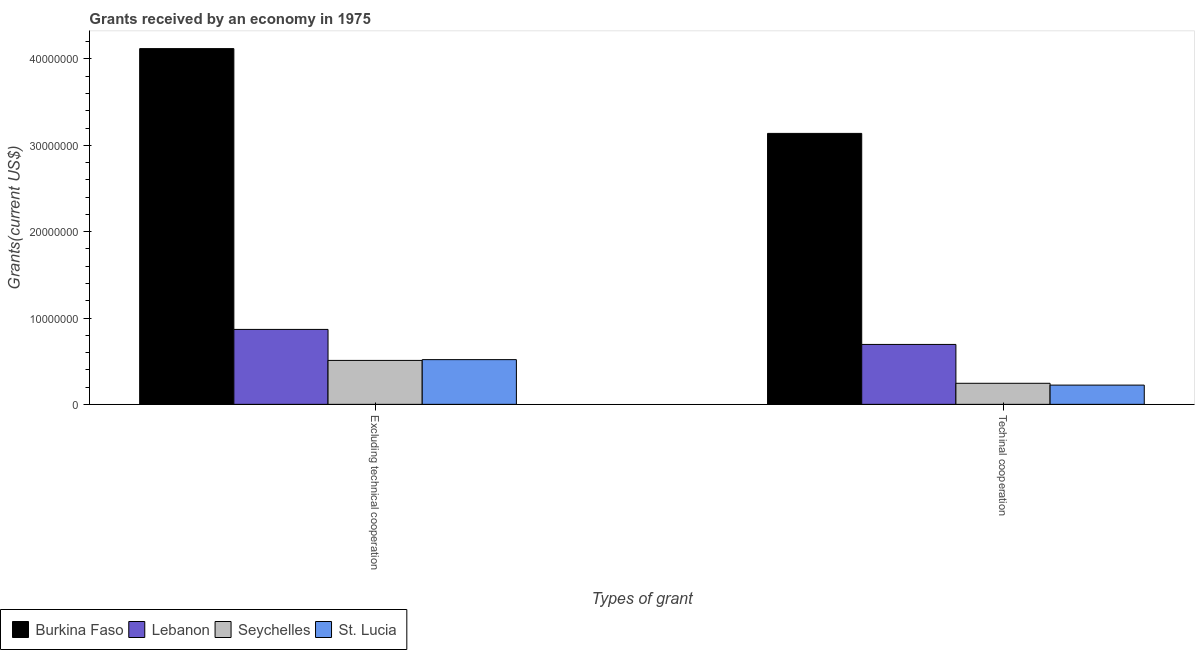How many groups of bars are there?
Your answer should be compact. 2. Are the number of bars on each tick of the X-axis equal?
Give a very brief answer. Yes. What is the label of the 2nd group of bars from the left?
Your answer should be compact. Techinal cooperation. What is the amount of grants received(including technical cooperation) in Seychelles?
Your response must be concise. 2.44e+06. Across all countries, what is the maximum amount of grants received(including technical cooperation)?
Keep it short and to the point. 3.14e+07. Across all countries, what is the minimum amount of grants received(including technical cooperation)?
Give a very brief answer. 2.23e+06. In which country was the amount of grants received(including technical cooperation) maximum?
Offer a very short reply. Burkina Faso. In which country was the amount of grants received(including technical cooperation) minimum?
Provide a succinct answer. St. Lucia. What is the total amount of grants received(including technical cooperation) in the graph?
Your answer should be compact. 4.30e+07. What is the difference between the amount of grants received(excluding technical cooperation) in Lebanon and that in Burkina Faso?
Provide a succinct answer. -3.25e+07. What is the difference between the amount of grants received(excluding technical cooperation) in Burkina Faso and the amount of grants received(including technical cooperation) in Seychelles?
Keep it short and to the point. 3.88e+07. What is the average amount of grants received(including technical cooperation) per country?
Your answer should be very brief. 1.07e+07. What is the difference between the amount of grants received(excluding technical cooperation) and amount of grants received(including technical cooperation) in Seychelles?
Offer a terse response. 2.65e+06. What is the ratio of the amount of grants received(including technical cooperation) in Seychelles to that in Burkina Faso?
Make the answer very short. 0.08. Is the amount of grants received(including technical cooperation) in Seychelles less than that in St. Lucia?
Your answer should be compact. No. In how many countries, is the amount of grants received(including technical cooperation) greater than the average amount of grants received(including technical cooperation) taken over all countries?
Your answer should be very brief. 1. What does the 3rd bar from the left in Techinal cooperation represents?
Make the answer very short. Seychelles. What does the 3rd bar from the right in Excluding technical cooperation represents?
Your answer should be very brief. Lebanon. How many bars are there?
Offer a terse response. 8. Are all the bars in the graph horizontal?
Your answer should be compact. No. How many countries are there in the graph?
Provide a succinct answer. 4. Does the graph contain any zero values?
Offer a very short reply. No. How many legend labels are there?
Provide a short and direct response. 4. What is the title of the graph?
Ensure brevity in your answer.  Grants received by an economy in 1975. What is the label or title of the X-axis?
Provide a succinct answer. Types of grant. What is the label or title of the Y-axis?
Keep it short and to the point. Grants(current US$). What is the Grants(current US$) of Burkina Faso in Excluding technical cooperation?
Ensure brevity in your answer.  4.12e+07. What is the Grants(current US$) in Lebanon in Excluding technical cooperation?
Your answer should be very brief. 8.68e+06. What is the Grants(current US$) in Seychelles in Excluding technical cooperation?
Provide a succinct answer. 5.09e+06. What is the Grants(current US$) of St. Lucia in Excluding technical cooperation?
Give a very brief answer. 5.18e+06. What is the Grants(current US$) in Burkina Faso in Techinal cooperation?
Keep it short and to the point. 3.14e+07. What is the Grants(current US$) in Lebanon in Techinal cooperation?
Offer a very short reply. 6.94e+06. What is the Grants(current US$) in Seychelles in Techinal cooperation?
Give a very brief answer. 2.44e+06. What is the Grants(current US$) of St. Lucia in Techinal cooperation?
Your response must be concise. 2.23e+06. Across all Types of grant, what is the maximum Grants(current US$) in Burkina Faso?
Provide a succinct answer. 4.12e+07. Across all Types of grant, what is the maximum Grants(current US$) in Lebanon?
Keep it short and to the point. 8.68e+06. Across all Types of grant, what is the maximum Grants(current US$) in Seychelles?
Make the answer very short. 5.09e+06. Across all Types of grant, what is the maximum Grants(current US$) in St. Lucia?
Provide a short and direct response. 5.18e+06. Across all Types of grant, what is the minimum Grants(current US$) in Burkina Faso?
Your answer should be compact. 3.14e+07. Across all Types of grant, what is the minimum Grants(current US$) of Lebanon?
Keep it short and to the point. 6.94e+06. Across all Types of grant, what is the minimum Grants(current US$) of Seychelles?
Provide a short and direct response. 2.44e+06. Across all Types of grant, what is the minimum Grants(current US$) in St. Lucia?
Your response must be concise. 2.23e+06. What is the total Grants(current US$) in Burkina Faso in the graph?
Give a very brief answer. 7.26e+07. What is the total Grants(current US$) in Lebanon in the graph?
Make the answer very short. 1.56e+07. What is the total Grants(current US$) of Seychelles in the graph?
Ensure brevity in your answer.  7.53e+06. What is the total Grants(current US$) of St. Lucia in the graph?
Offer a very short reply. 7.41e+06. What is the difference between the Grants(current US$) of Burkina Faso in Excluding technical cooperation and that in Techinal cooperation?
Provide a succinct answer. 9.82e+06. What is the difference between the Grants(current US$) in Lebanon in Excluding technical cooperation and that in Techinal cooperation?
Your answer should be compact. 1.74e+06. What is the difference between the Grants(current US$) of Seychelles in Excluding technical cooperation and that in Techinal cooperation?
Give a very brief answer. 2.65e+06. What is the difference between the Grants(current US$) in St. Lucia in Excluding technical cooperation and that in Techinal cooperation?
Your answer should be very brief. 2.95e+06. What is the difference between the Grants(current US$) of Burkina Faso in Excluding technical cooperation and the Grants(current US$) of Lebanon in Techinal cooperation?
Provide a succinct answer. 3.43e+07. What is the difference between the Grants(current US$) of Burkina Faso in Excluding technical cooperation and the Grants(current US$) of Seychelles in Techinal cooperation?
Your answer should be compact. 3.88e+07. What is the difference between the Grants(current US$) of Burkina Faso in Excluding technical cooperation and the Grants(current US$) of St. Lucia in Techinal cooperation?
Offer a very short reply. 3.90e+07. What is the difference between the Grants(current US$) in Lebanon in Excluding technical cooperation and the Grants(current US$) in Seychelles in Techinal cooperation?
Ensure brevity in your answer.  6.24e+06. What is the difference between the Grants(current US$) of Lebanon in Excluding technical cooperation and the Grants(current US$) of St. Lucia in Techinal cooperation?
Provide a short and direct response. 6.45e+06. What is the difference between the Grants(current US$) of Seychelles in Excluding technical cooperation and the Grants(current US$) of St. Lucia in Techinal cooperation?
Offer a terse response. 2.86e+06. What is the average Grants(current US$) in Burkina Faso per Types of grant?
Make the answer very short. 3.63e+07. What is the average Grants(current US$) in Lebanon per Types of grant?
Offer a very short reply. 7.81e+06. What is the average Grants(current US$) in Seychelles per Types of grant?
Ensure brevity in your answer.  3.76e+06. What is the average Grants(current US$) of St. Lucia per Types of grant?
Give a very brief answer. 3.70e+06. What is the difference between the Grants(current US$) in Burkina Faso and Grants(current US$) in Lebanon in Excluding technical cooperation?
Offer a terse response. 3.25e+07. What is the difference between the Grants(current US$) in Burkina Faso and Grants(current US$) in Seychelles in Excluding technical cooperation?
Keep it short and to the point. 3.61e+07. What is the difference between the Grants(current US$) of Burkina Faso and Grants(current US$) of St. Lucia in Excluding technical cooperation?
Give a very brief answer. 3.60e+07. What is the difference between the Grants(current US$) in Lebanon and Grants(current US$) in Seychelles in Excluding technical cooperation?
Offer a terse response. 3.59e+06. What is the difference between the Grants(current US$) of Lebanon and Grants(current US$) of St. Lucia in Excluding technical cooperation?
Offer a terse response. 3.50e+06. What is the difference between the Grants(current US$) of Seychelles and Grants(current US$) of St. Lucia in Excluding technical cooperation?
Make the answer very short. -9.00e+04. What is the difference between the Grants(current US$) of Burkina Faso and Grants(current US$) of Lebanon in Techinal cooperation?
Make the answer very short. 2.44e+07. What is the difference between the Grants(current US$) in Burkina Faso and Grants(current US$) in Seychelles in Techinal cooperation?
Provide a succinct answer. 2.89e+07. What is the difference between the Grants(current US$) of Burkina Faso and Grants(current US$) of St. Lucia in Techinal cooperation?
Give a very brief answer. 2.92e+07. What is the difference between the Grants(current US$) of Lebanon and Grants(current US$) of Seychelles in Techinal cooperation?
Provide a succinct answer. 4.50e+06. What is the difference between the Grants(current US$) in Lebanon and Grants(current US$) in St. Lucia in Techinal cooperation?
Make the answer very short. 4.71e+06. What is the ratio of the Grants(current US$) in Burkina Faso in Excluding technical cooperation to that in Techinal cooperation?
Provide a short and direct response. 1.31. What is the ratio of the Grants(current US$) of Lebanon in Excluding technical cooperation to that in Techinal cooperation?
Your answer should be very brief. 1.25. What is the ratio of the Grants(current US$) of Seychelles in Excluding technical cooperation to that in Techinal cooperation?
Provide a succinct answer. 2.09. What is the ratio of the Grants(current US$) of St. Lucia in Excluding technical cooperation to that in Techinal cooperation?
Ensure brevity in your answer.  2.32. What is the difference between the highest and the second highest Grants(current US$) of Burkina Faso?
Make the answer very short. 9.82e+06. What is the difference between the highest and the second highest Grants(current US$) in Lebanon?
Your answer should be very brief. 1.74e+06. What is the difference between the highest and the second highest Grants(current US$) of Seychelles?
Your answer should be very brief. 2.65e+06. What is the difference between the highest and the second highest Grants(current US$) of St. Lucia?
Give a very brief answer. 2.95e+06. What is the difference between the highest and the lowest Grants(current US$) of Burkina Faso?
Provide a short and direct response. 9.82e+06. What is the difference between the highest and the lowest Grants(current US$) in Lebanon?
Provide a succinct answer. 1.74e+06. What is the difference between the highest and the lowest Grants(current US$) of Seychelles?
Your answer should be compact. 2.65e+06. What is the difference between the highest and the lowest Grants(current US$) of St. Lucia?
Give a very brief answer. 2.95e+06. 